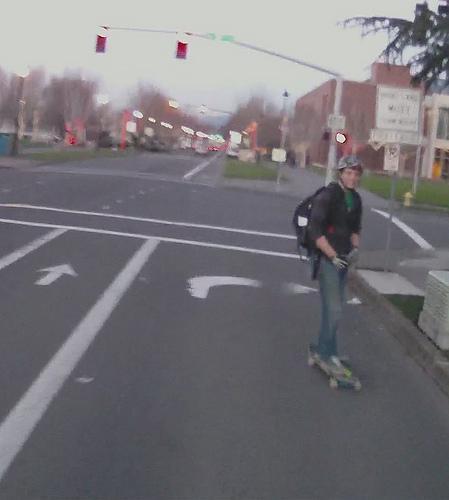How many arrows are in the road?
Give a very brief answer. 2. 